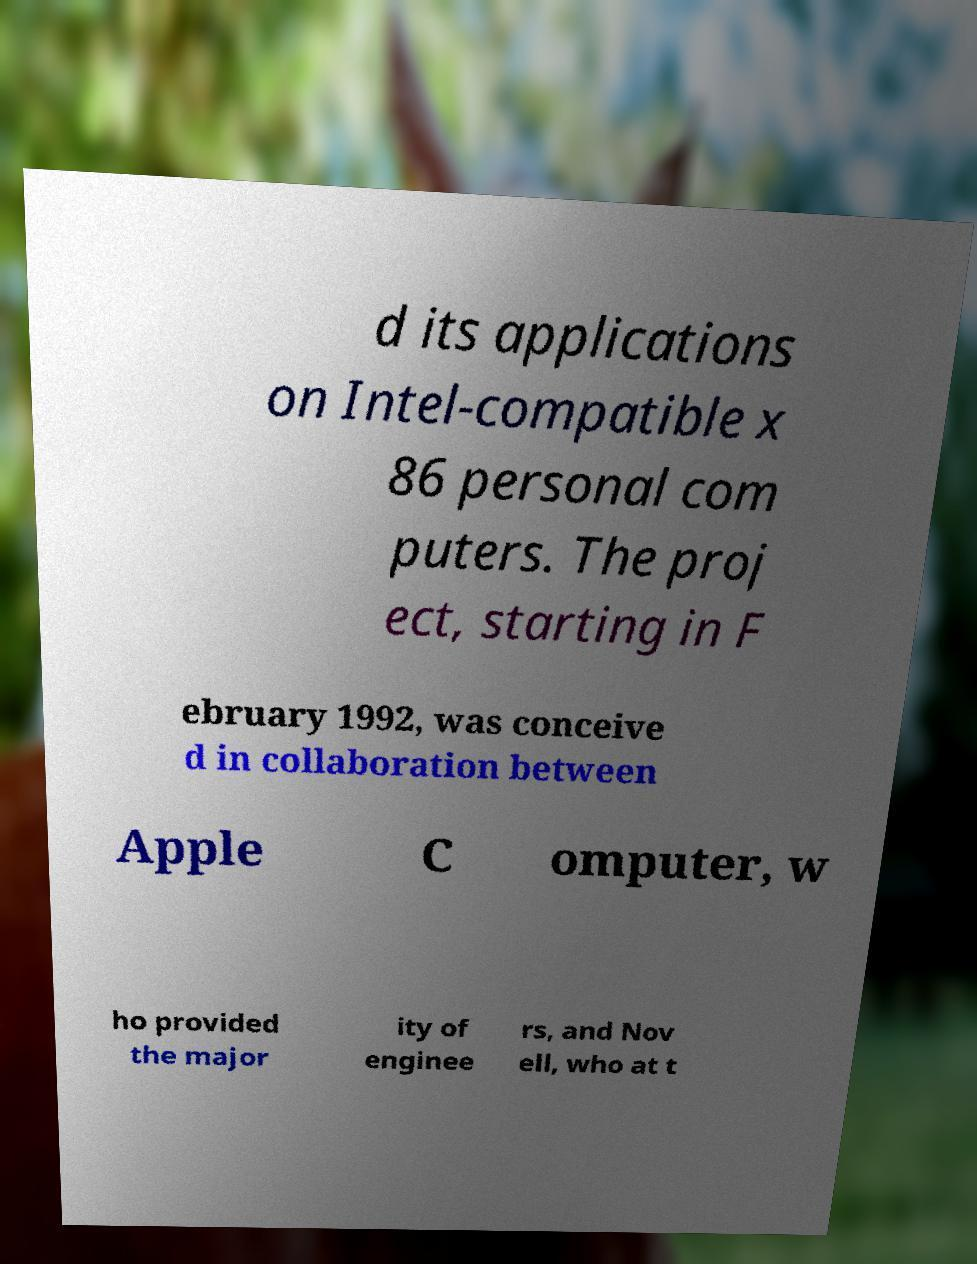Could you assist in decoding the text presented in this image and type it out clearly? d its applications on Intel-compatible x 86 personal com puters. The proj ect, starting in F ebruary 1992, was conceive d in collaboration between Apple C omputer, w ho provided the major ity of enginee rs, and Nov ell, who at t 